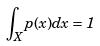Convert formula to latex. <formula><loc_0><loc_0><loc_500><loc_500>\int _ { X } p ( x ) d x = 1</formula> 